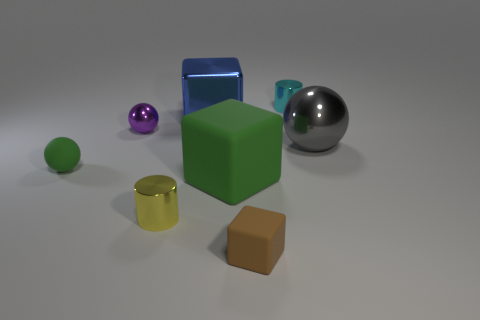There is a small thing that is behind the gray thing and to the left of the tiny cyan cylinder; what is its shape? The small object you're referring to behind the gray sphere and to the left of the tiny cyan cylinder is a purple sphere. Its shape is perfectly spherical, evident by its uniform contours and reflections. 